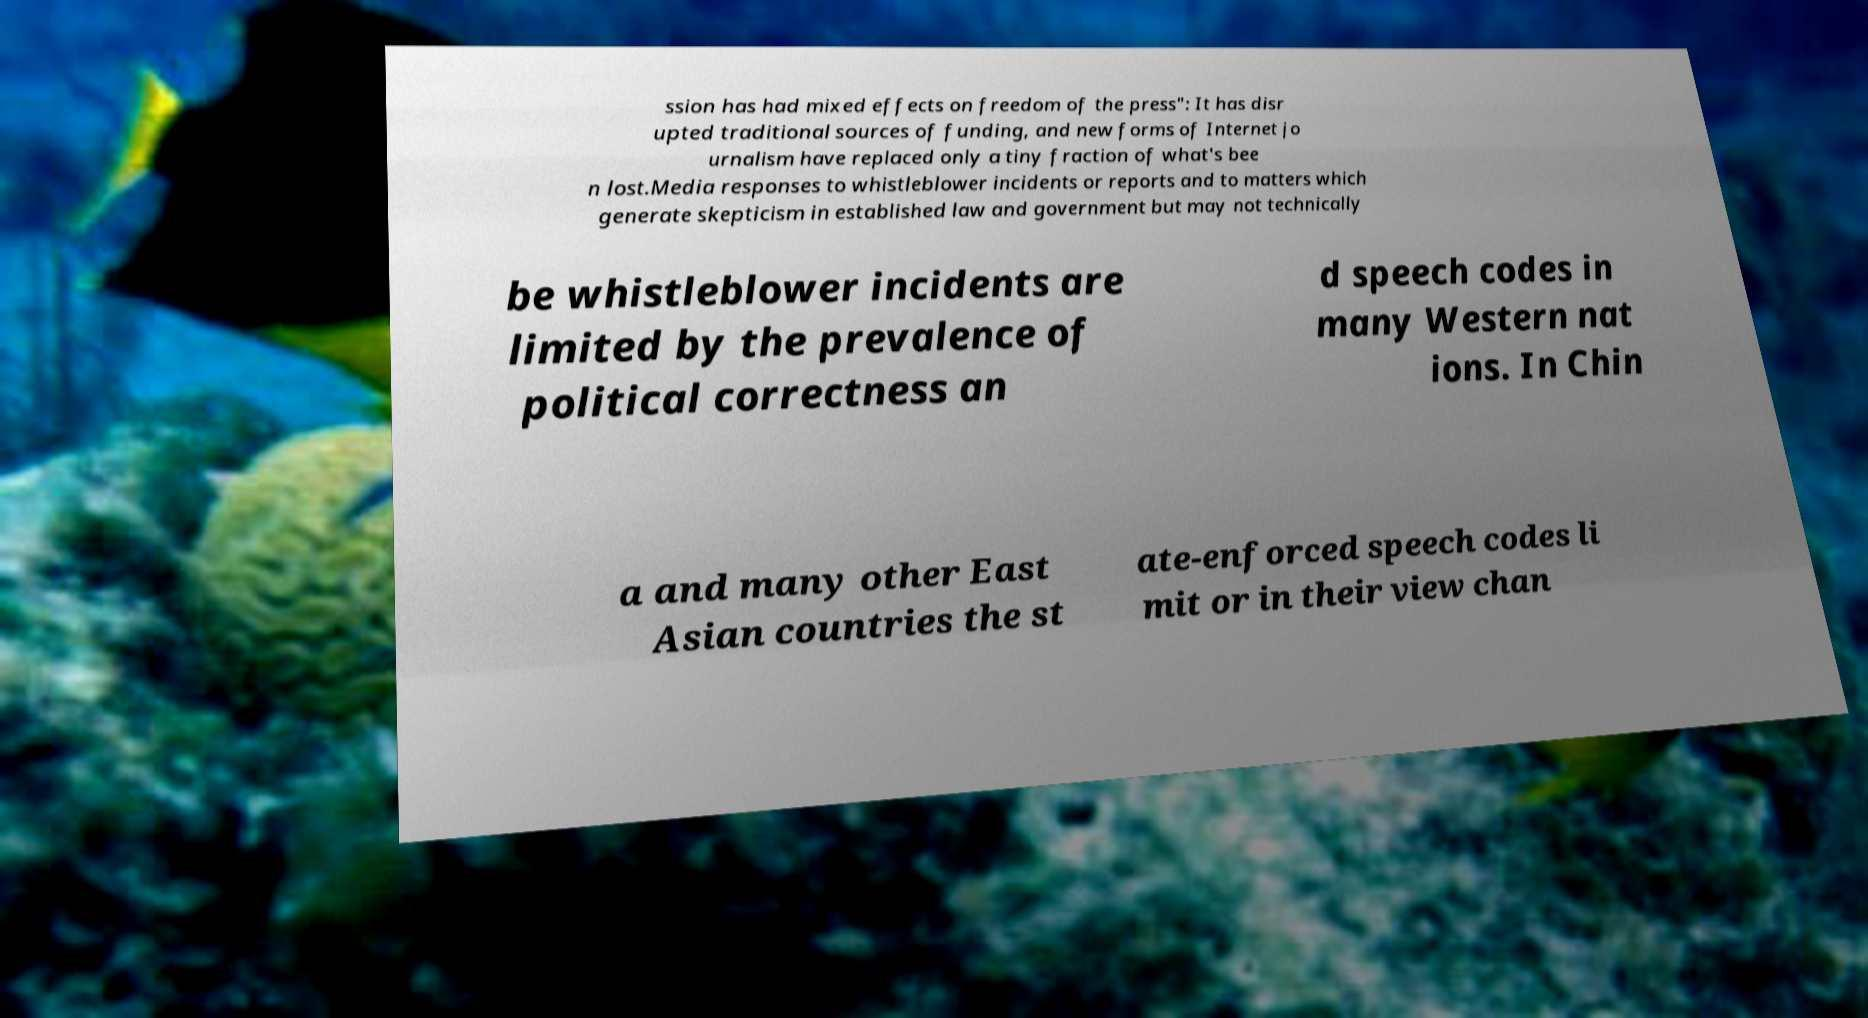Can you read and provide the text displayed in the image?This photo seems to have some interesting text. Can you extract and type it out for me? ssion has had mixed effects on freedom of the press": It has disr upted traditional sources of funding, and new forms of Internet jo urnalism have replaced only a tiny fraction of what's bee n lost.Media responses to whistleblower incidents or reports and to matters which generate skepticism in established law and government but may not technically be whistleblower incidents are limited by the prevalence of political correctness an d speech codes in many Western nat ions. In Chin a and many other East Asian countries the st ate-enforced speech codes li mit or in their view chan 